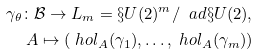<formula> <loc_0><loc_0><loc_500><loc_500>\gamma _ { \theta } \colon { \mathcal { B } } \to L _ { m } = \S U ( 2 ) ^ { m } / \ a d \S U ( 2 ) , \\ A \mapsto ( \ h o l _ { A } ( \gamma _ { 1 } ) , \dots , \ h o l _ { A } ( \gamma _ { m } ) )</formula> 